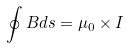Convert formula to latex. <formula><loc_0><loc_0><loc_500><loc_500>\oint B d s = \mu _ { 0 } \times I</formula> 